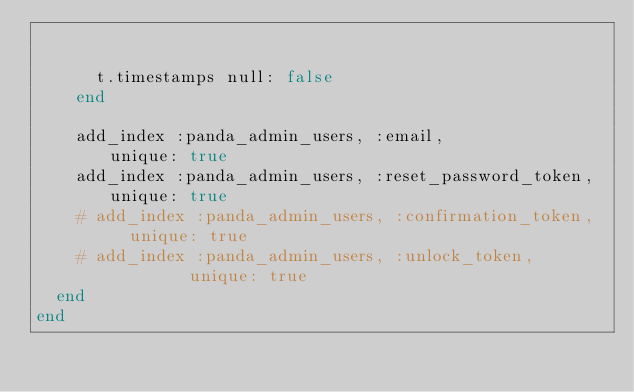<code> <loc_0><loc_0><loc_500><loc_500><_Ruby_>

      t.timestamps null: false
    end

    add_index :panda_admin_users, :email,                unique: true
    add_index :panda_admin_users, :reset_password_token, unique: true
    # add_index :panda_admin_users, :confirmation_token,   unique: true
    # add_index :panda_admin_users, :unlock_token,         unique: true
  end
end
</code> 